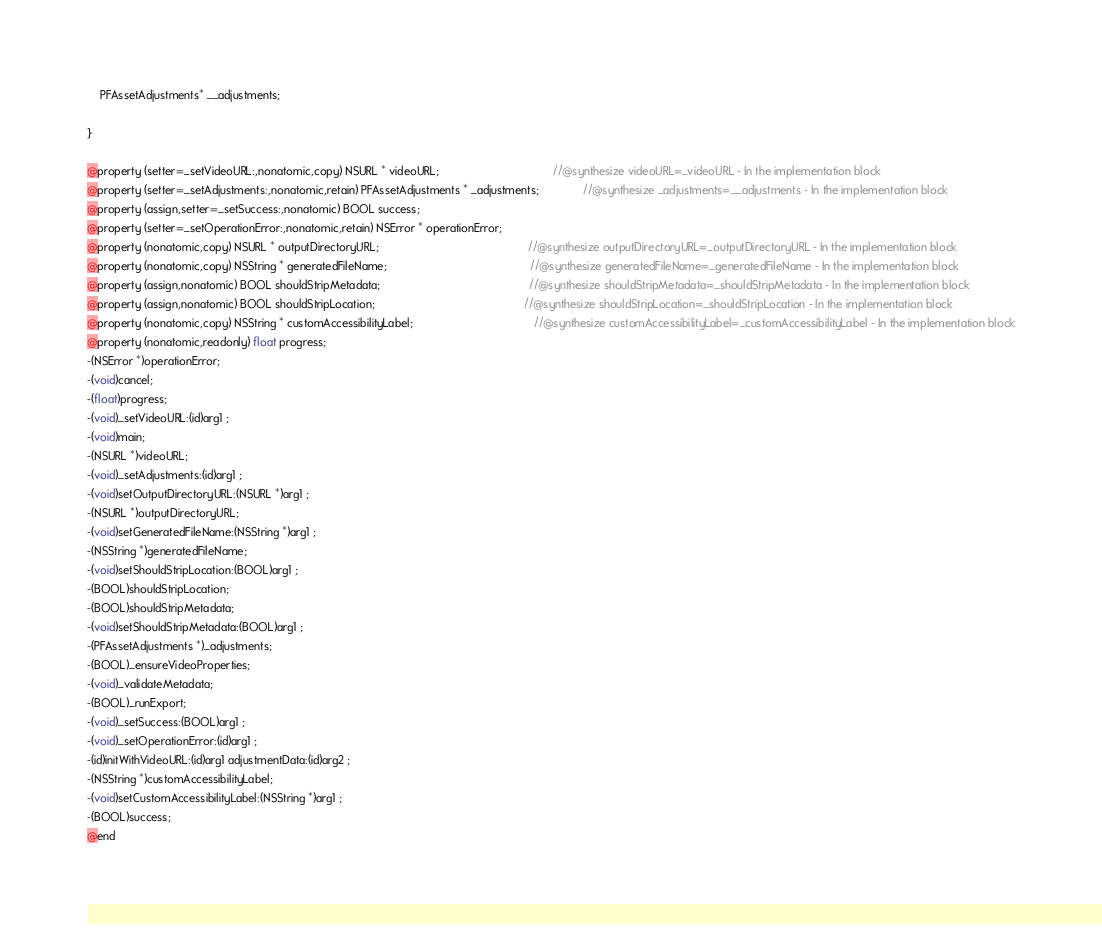<code> <loc_0><loc_0><loc_500><loc_500><_C_>	PFAssetAdjustments* __adjustments;

}

@property (setter=_setVideoURL:,nonatomic,copy) NSURL * videoURL;                                    //@synthesize videoURL=_videoURL - In the implementation block
@property (setter=_setAdjustments:,nonatomic,retain) PFAssetAdjustments * _adjustments;              //@synthesize _adjustments=__adjustments - In the implementation block
@property (assign,setter=_setSuccess:,nonatomic) BOOL success; 
@property (setter=_setOperationError:,nonatomic,retain) NSError * operationError; 
@property (nonatomic,copy) NSURL * outputDirectoryURL;                                               //@synthesize outputDirectoryURL=_outputDirectoryURL - In the implementation block
@property (nonatomic,copy) NSString * generatedFileName;                                             //@synthesize generatedFileName=_generatedFileName - In the implementation block
@property (assign,nonatomic) BOOL shouldStripMetadata;                                               //@synthesize shouldStripMetadata=_shouldStripMetadata - In the implementation block
@property (assign,nonatomic) BOOL shouldStripLocation;                                               //@synthesize shouldStripLocation=_shouldStripLocation - In the implementation block
@property (nonatomic,copy) NSString * customAccessibilityLabel;                                      //@synthesize customAccessibilityLabel=_customAccessibilityLabel - In the implementation block
@property (nonatomic,readonly) float progress; 
-(NSError *)operationError;
-(void)cancel;
-(float)progress;
-(void)_setVideoURL:(id)arg1 ;
-(void)main;
-(NSURL *)videoURL;
-(void)_setAdjustments:(id)arg1 ;
-(void)setOutputDirectoryURL:(NSURL *)arg1 ;
-(NSURL *)outputDirectoryURL;
-(void)setGeneratedFileName:(NSString *)arg1 ;
-(NSString *)generatedFileName;
-(void)setShouldStripLocation:(BOOL)arg1 ;
-(BOOL)shouldStripLocation;
-(BOOL)shouldStripMetadata;
-(void)setShouldStripMetadata:(BOOL)arg1 ;
-(PFAssetAdjustments *)_adjustments;
-(BOOL)_ensureVideoProperties;
-(void)_validateMetadata;
-(BOOL)_runExport;
-(void)_setSuccess:(BOOL)arg1 ;
-(void)_setOperationError:(id)arg1 ;
-(id)initWithVideoURL:(id)arg1 adjustmentData:(id)arg2 ;
-(NSString *)customAccessibilityLabel;
-(void)setCustomAccessibilityLabel:(NSString *)arg1 ;
-(BOOL)success;
@end

</code> 